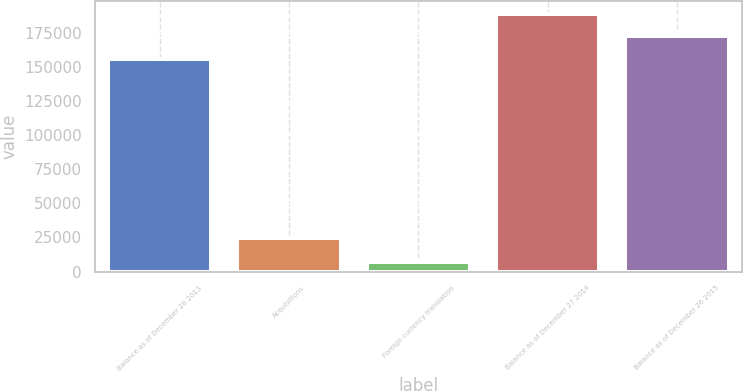Convert chart to OTSL. <chart><loc_0><loc_0><loc_500><loc_500><bar_chart><fcel>Balance as of December 28 2013<fcel>Acquisitions<fcel>Foreign currency translation<fcel>Balance as of December 27 2014<fcel>Balance as of December 26 2015<nl><fcel>155828<fcel>24457<fcel>6716<fcel>189199<fcel>172513<nl></chart> 